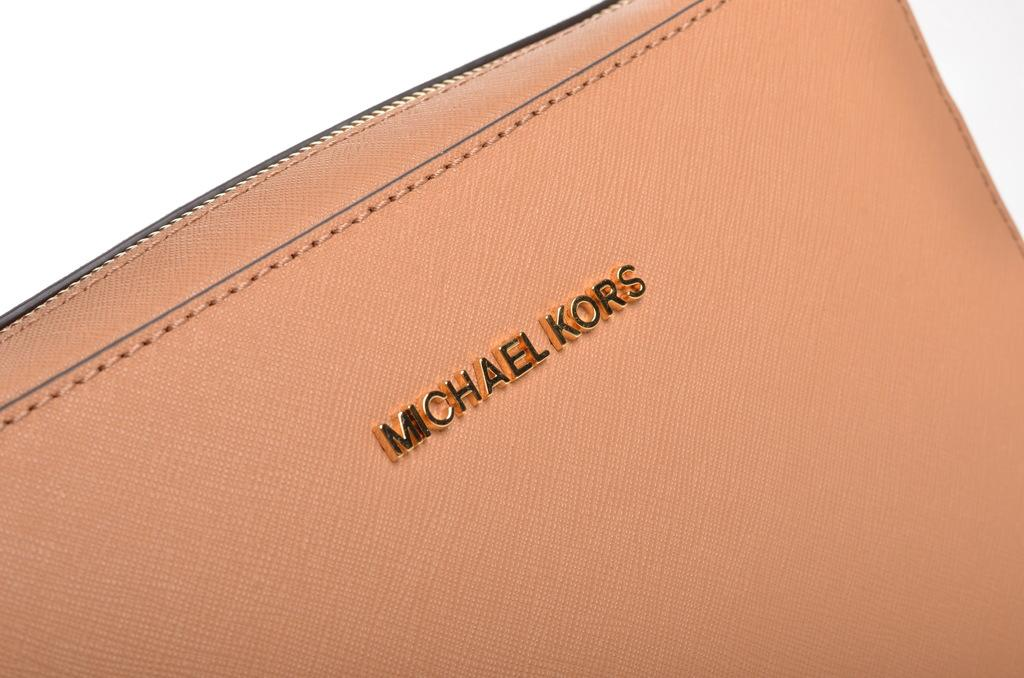What object can be seen in the image? There is a purse in the image. What is featured on the purse? There is text written on the purse. What type of toothpaste is visible in the image? There is no toothpaste present in the image. How does the sock contribute to the design of the purse in the image? There is no sock present in the image. 